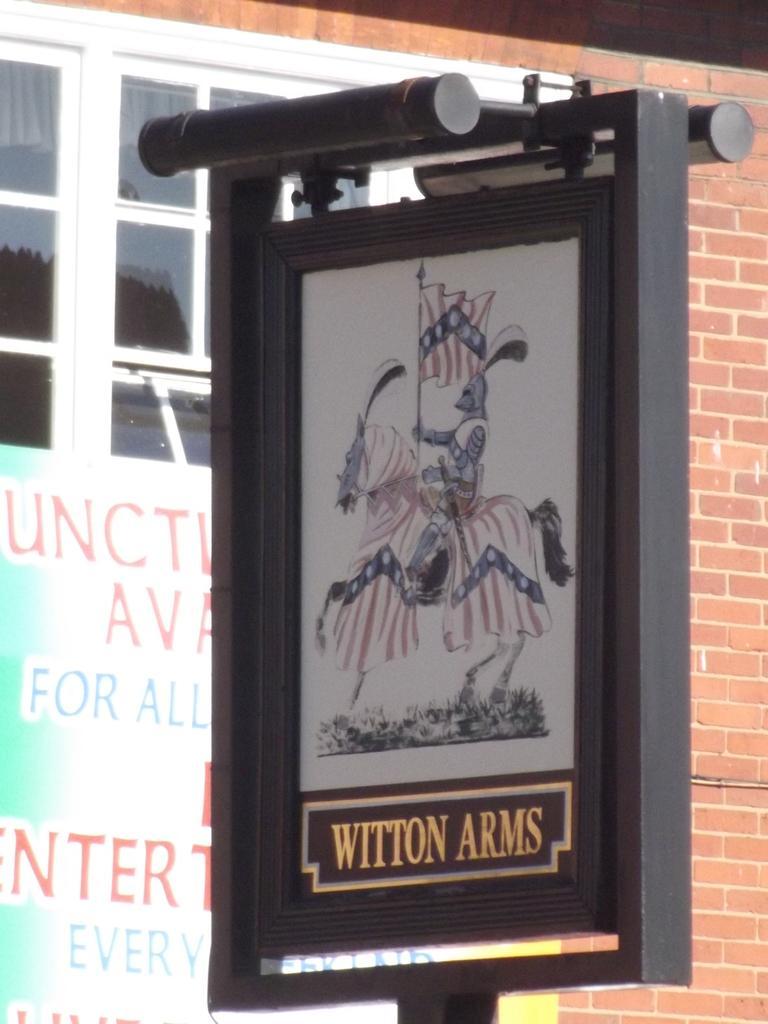In one or two sentences, can you explain what this image depicts? In the image there is a black frame board with a poster. On the poster there is an image and something written on it. Behind the poster there is a brick wall with glass window and also there is a poster with something written on it. 